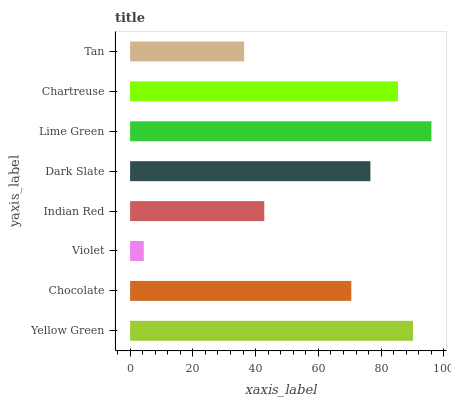Is Violet the minimum?
Answer yes or no. Yes. Is Lime Green the maximum?
Answer yes or no. Yes. Is Chocolate the minimum?
Answer yes or no. No. Is Chocolate the maximum?
Answer yes or no. No. Is Yellow Green greater than Chocolate?
Answer yes or no. Yes. Is Chocolate less than Yellow Green?
Answer yes or no. Yes. Is Chocolate greater than Yellow Green?
Answer yes or no. No. Is Yellow Green less than Chocolate?
Answer yes or no. No. Is Dark Slate the high median?
Answer yes or no. Yes. Is Chocolate the low median?
Answer yes or no. Yes. Is Chocolate the high median?
Answer yes or no. No. Is Chartreuse the low median?
Answer yes or no. No. 